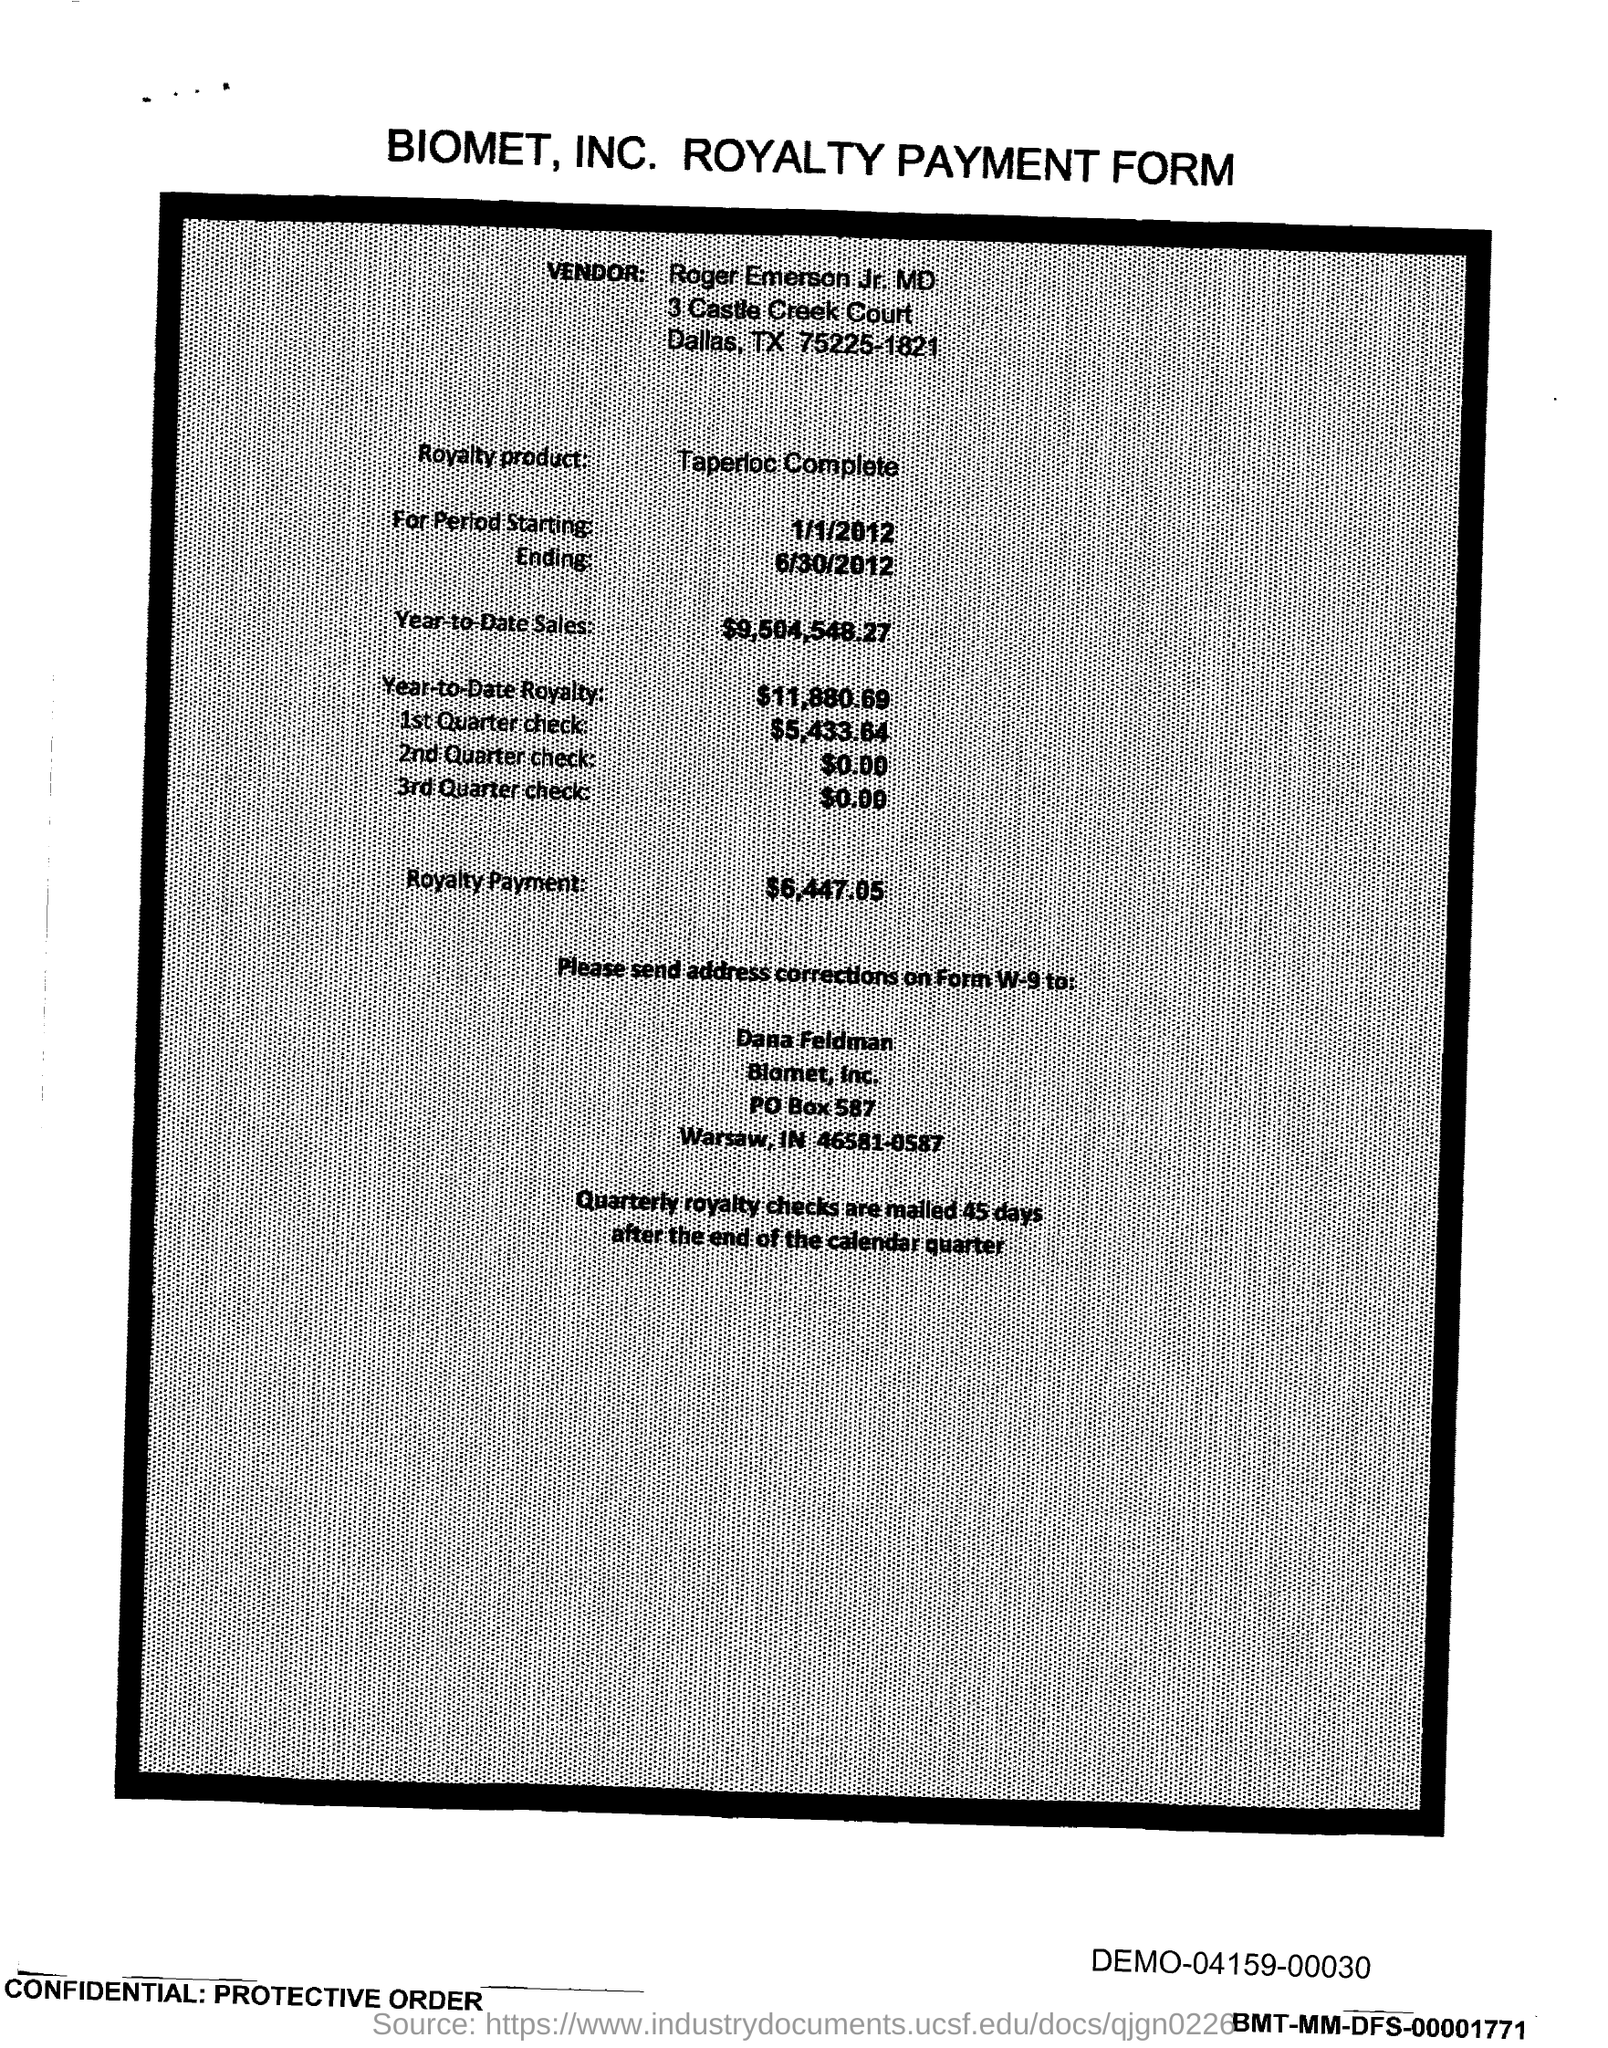What is the PO Box Number mentioned in the document?
Your response must be concise. 587. 